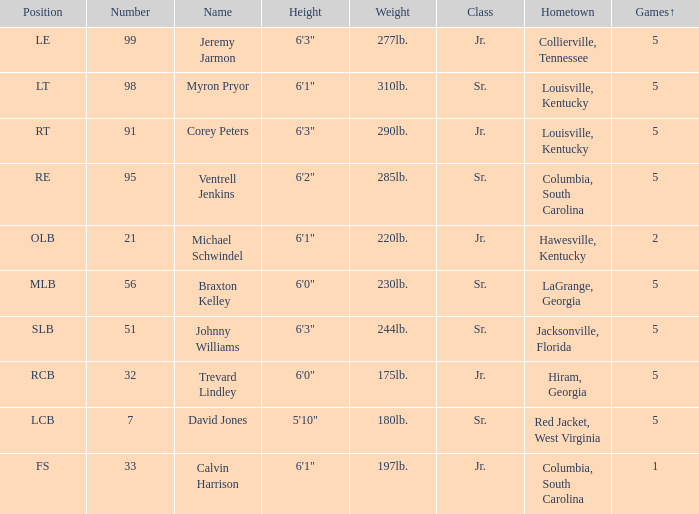What was Trevard Lindley's number? 32.0. 